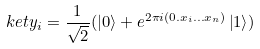<formula> <loc_0><loc_0><loc_500><loc_500>\ k e t { y _ { i } } = \frac { 1 } { \sqrt { 2 } } ( \left | 0 \right > + e ^ { 2 \pi i ( 0 . x _ { i } \dots x _ { n } ) } \left | 1 \right > )</formula> 